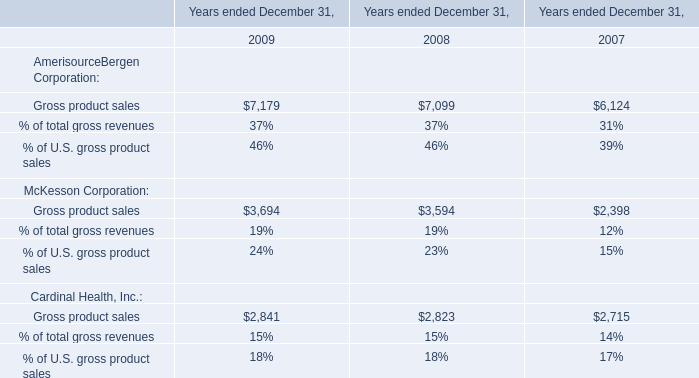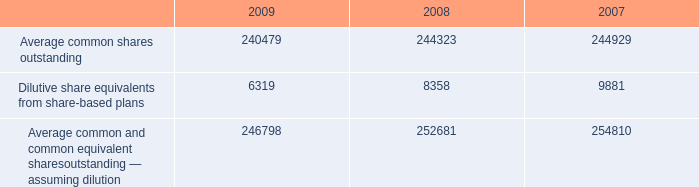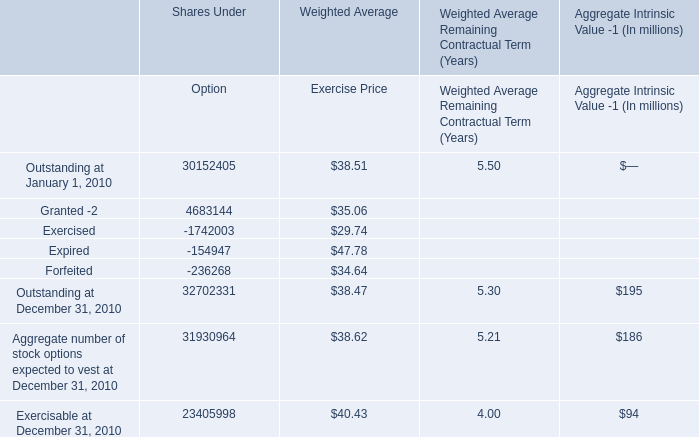Which part of Weighted Average Exercise Price of total Outstanding at January 1, 2010 exceeds 90 % of Weighted Average Exercise Price of total Outstanding at January 1, 2010？ 
Answer: Granted Outstanding and Expired Outstanding. 